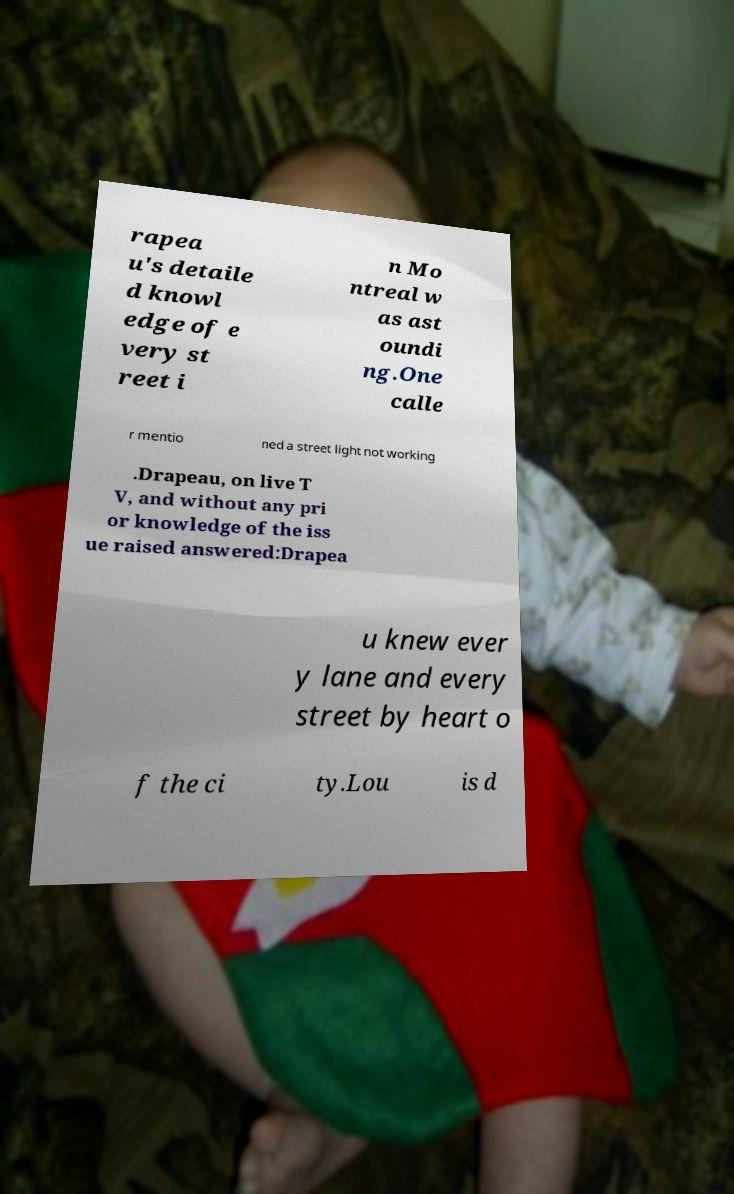What messages or text are displayed in this image? I need them in a readable, typed format. rapea u's detaile d knowl edge of e very st reet i n Mo ntreal w as ast oundi ng.One calle r mentio ned a street light not working .Drapeau, on live T V, and without any pri or knowledge of the iss ue raised answered:Drapea u knew ever y lane and every street by heart o f the ci ty.Lou is d 